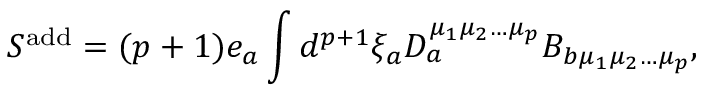Convert formula to latex. <formula><loc_0><loc_0><loc_500><loc_500>S ^ { a d d } = ( p + 1 ) e _ { a } \int d ^ { p + 1 } \xi _ { a } D _ { a } ^ { \mu _ { 1 } \mu _ { 2 } \dots \mu _ { p } } B _ { b \mu _ { 1 } \mu _ { 2 } \dots \mu _ { p } } ,</formula> 